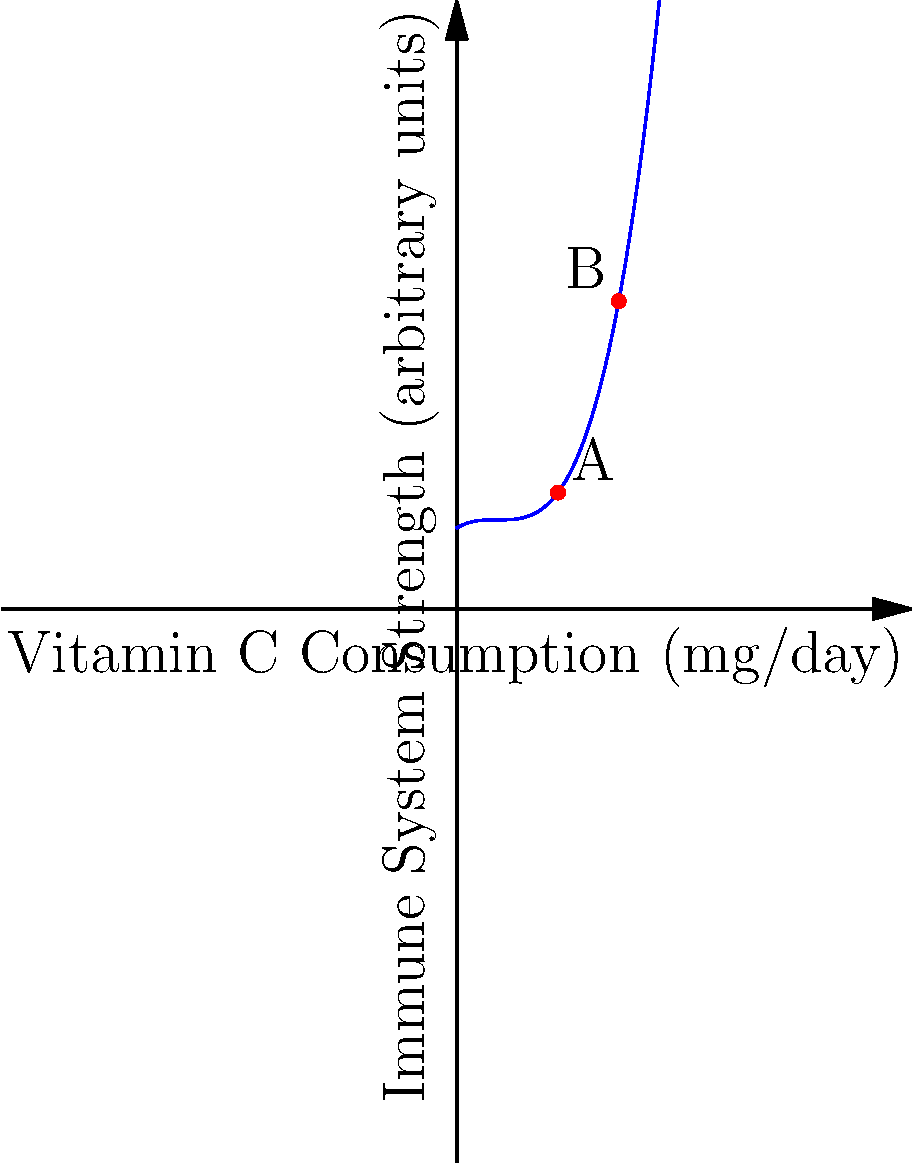The graph shows a polynomial regression curve depicting the relationship between daily vitamin C consumption and immune system strength. At point A, the vitamin C consumption is 50 mg/day. What is the approximate vitamin C consumption at point B, and how does the rate of change in immune system strength compare between points A and B? To answer this question, we need to analyze the graph and compare the two points:

1. Identify point A:
   - Point A is at x = 50 mg/day of vitamin C consumption

2. Estimate point B's x-coordinate:
   - Point B appears to be at approximately x = 80 mg/day of vitamin C consumption

3. Compare the rate of change (slope) at points A and B:
   - At point A, the curve is steeper, indicating a higher positive rate of change
   - At point B, the curve is less steep and starting to level off, indicating a lower positive rate of change

4. Interpret the relationship:
   - The rate of change in immune system strength is higher at point A (50 mg/day) compared to point B (80 mg/day)
   - This suggests that increasing vitamin C consumption from 50 to 80 mg/day results in diminishing returns on immune system strength

5. Formulate the answer:
   - Point B is at approximately 80 mg/day of vitamin C consumption
   - The rate of change in immune system strength is lower at point B compared to point A
Answer: Approximately 80 mg/day; lower rate of change at B 